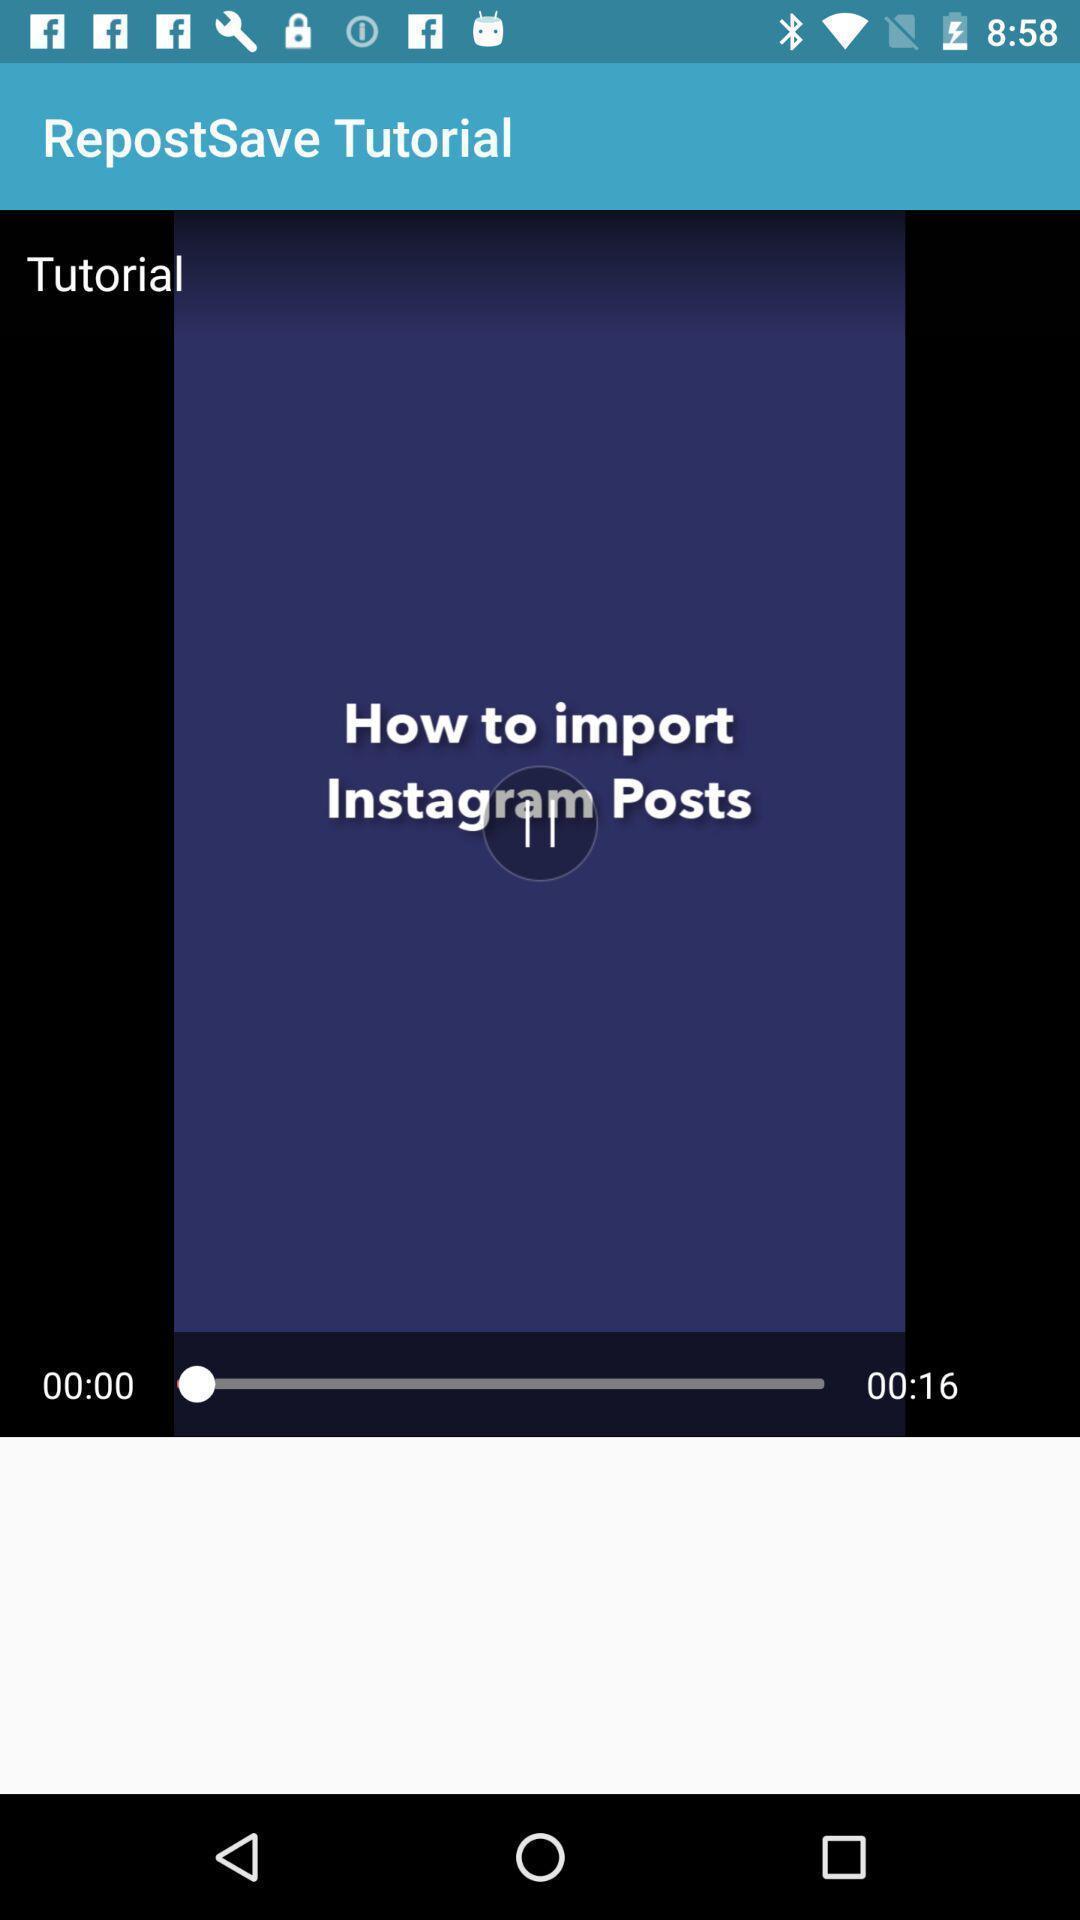Please provide a description for this image. Screen shows a tutorial on how to import. 